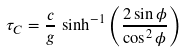Convert formula to latex. <formula><loc_0><loc_0><loc_500><loc_500>\tau _ { C } = \frac { c } { g } \, \sinh ^ { - 1 } \left ( \frac { 2 \sin \phi } { \cos ^ { 2 } \phi } \right )</formula> 